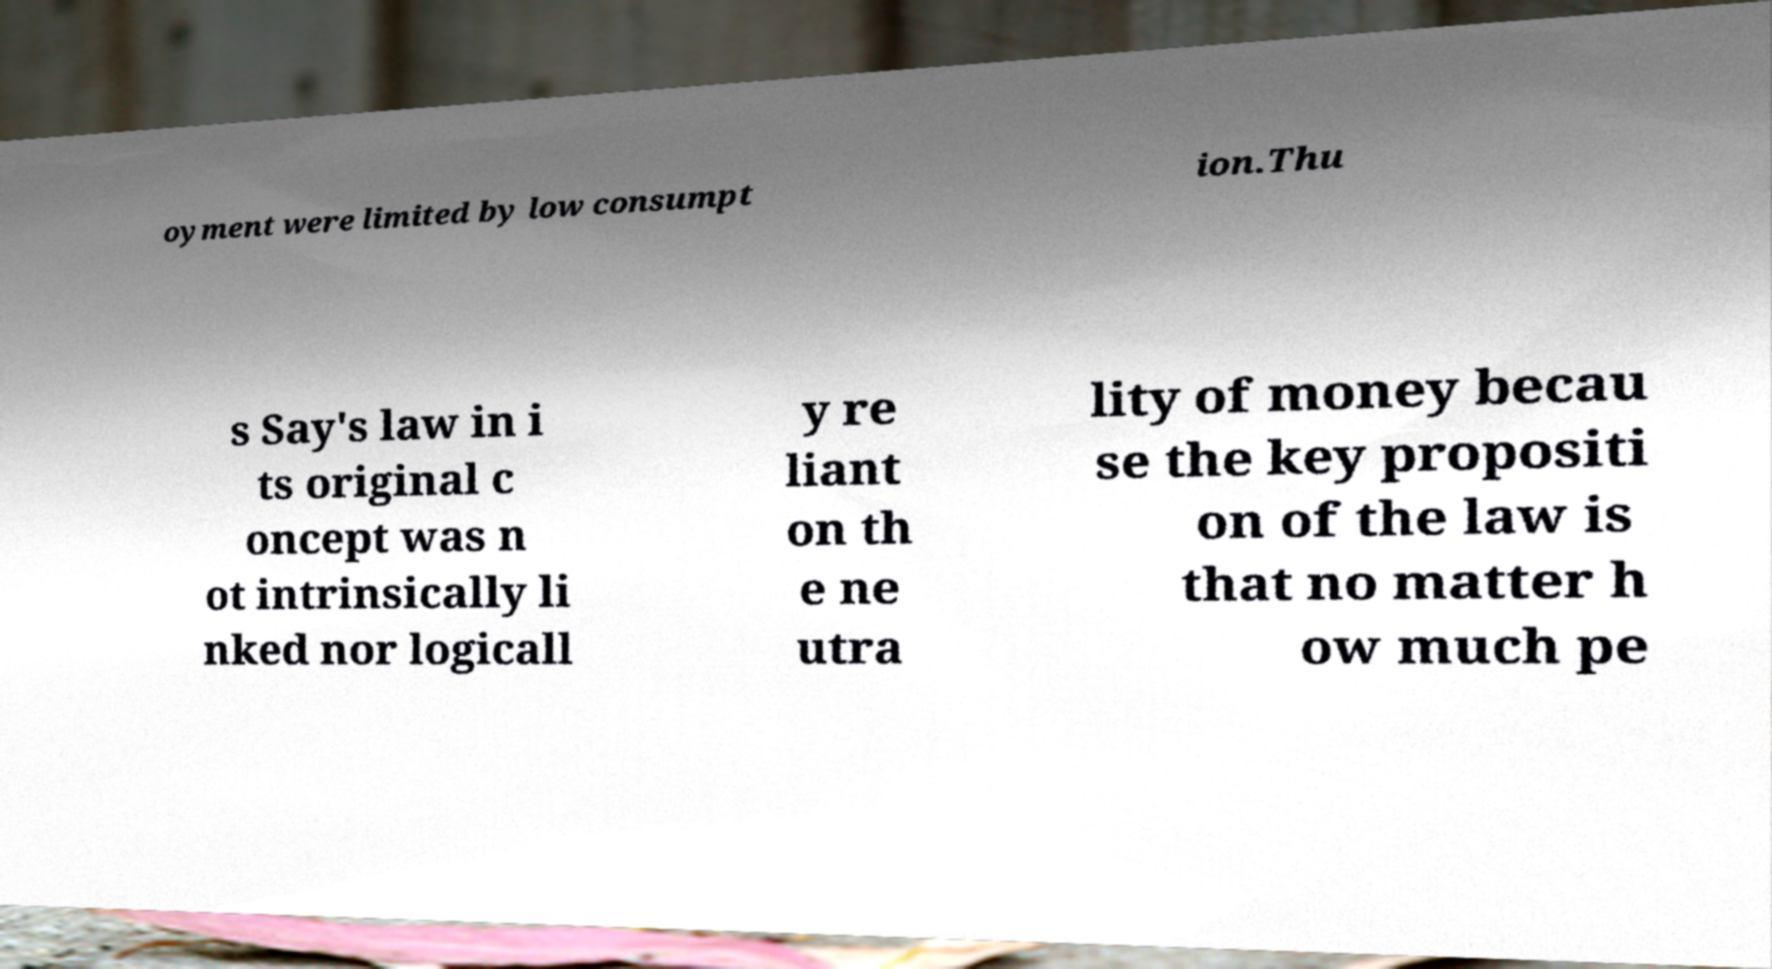Please identify and transcribe the text found in this image. oyment were limited by low consumpt ion.Thu s Say's law in i ts original c oncept was n ot intrinsically li nked nor logicall y re liant on th e ne utra lity of money becau se the key propositi on of the law is that no matter h ow much pe 